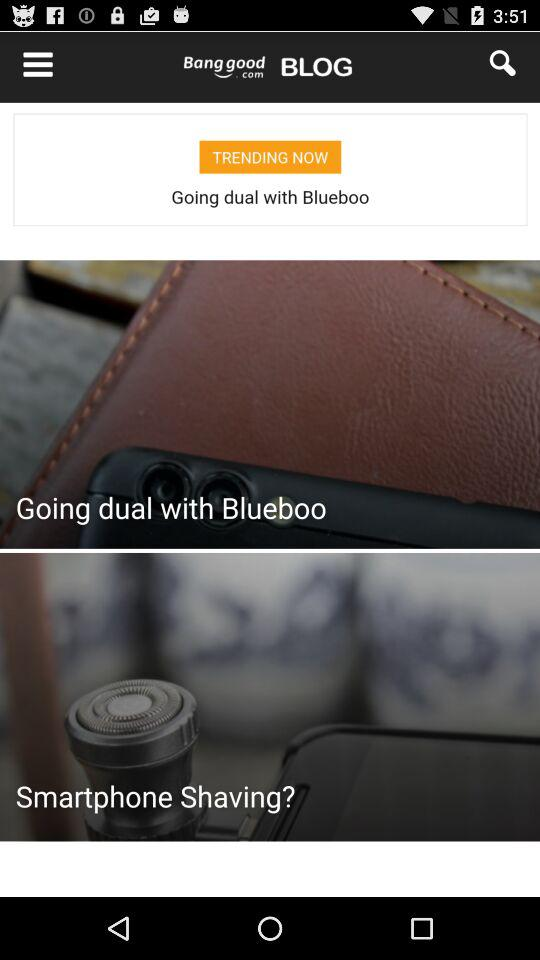What is the count of reviews? The count of reviews is 6. 